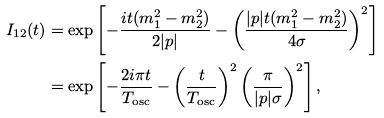<formula> <loc_0><loc_0><loc_500><loc_500>I _ { 1 2 } ( t ) & = \exp \left [ - \frac { i t ( m _ { 1 } ^ { 2 } - m _ { 2 } ^ { 2 } ) } { 2 | p | } - \left ( \frac { | p | t ( m _ { 1 } ^ { 2 } - m _ { 2 } ^ { 2 } ) } { 4 \sigma } \right ) ^ { 2 } \right ] \\ & = \exp \left [ - \frac { 2 i \pi t } { T _ { \text {osc} } } - \left ( \frac { t } { T _ { \text {osc} } } \right ) ^ { 2 } \left ( \frac { \pi } { | p | \sigma } \right ) ^ { 2 } \right ] ,</formula> 